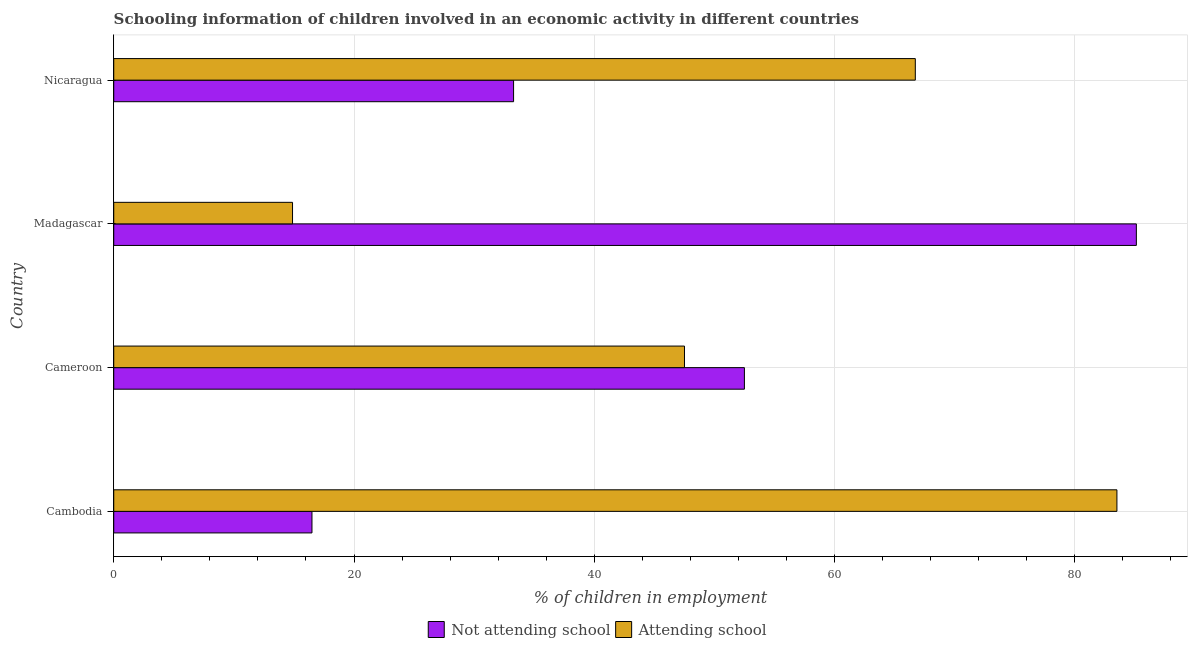Are the number of bars per tick equal to the number of legend labels?
Your response must be concise. Yes. Are the number of bars on each tick of the Y-axis equal?
Your answer should be compact. Yes. How many bars are there on the 2nd tick from the bottom?
Your answer should be very brief. 2. What is the label of the 1st group of bars from the top?
Your answer should be compact. Nicaragua. What is the percentage of employed children who are not attending school in Madagascar?
Your answer should be very brief. 85.12. Across all countries, what is the maximum percentage of employed children who are attending school?
Offer a very short reply. 83.5. Across all countries, what is the minimum percentage of employed children who are not attending school?
Keep it short and to the point. 16.5. In which country was the percentage of employed children who are not attending school maximum?
Your response must be concise. Madagascar. In which country was the percentage of employed children who are attending school minimum?
Provide a short and direct response. Madagascar. What is the total percentage of employed children who are not attending school in the graph?
Provide a short and direct response. 187.39. What is the difference between the percentage of employed children who are not attending school in Cameroon and that in Nicaragua?
Give a very brief answer. 19.21. What is the difference between the percentage of employed children who are not attending school in Madagascar and the percentage of employed children who are attending school in Cambodia?
Your response must be concise. 1.62. What is the average percentage of employed children who are attending school per country?
Ensure brevity in your answer.  53.15. In how many countries, is the percentage of employed children who are attending school greater than 60 %?
Provide a short and direct response. 2. What is the ratio of the percentage of employed children who are not attending school in Cameroon to that in Nicaragua?
Your answer should be very brief. 1.58. Is the percentage of employed children who are attending school in Cambodia less than that in Cameroon?
Keep it short and to the point. No. Is the difference between the percentage of employed children who are not attending school in Cambodia and Madagascar greater than the difference between the percentage of employed children who are attending school in Cambodia and Madagascar?
Your response must be concise. No. What is the difference between the highest and the second highest percentage of employed children who are attending school?
Offer a terse response. 16.78. What is the difference between the highest and the lowest percentage of employed children who are attending school?
Your answer should be very brief. 68.62. Is the sum of the percentage of employed children who are attending school in Cameroon and Nicaragua greater than the maximum percentage of employed children who are not attending school across all countries?
Provide a succinct answer. Yes. What does the 2nd bar from the top in Nicaragua represents?
Make the answer very short. Not attending school. What does the 1st bar from the bottom in Cambodia represents?
Ensure brevity in your answer.  Not attending school. Are the values on the major ticks of X-axis written in scientific E-notation?
Ensure brevity in your answer.  No. Does the graph contain any zero values?
Keep it short and to the point. No. How many legend labels are there?
Your response must be concise. 2. How are the legend labels stacked?
Offer a very short reply. Horizontal. What is the title of the graph?
Your answer should be compact. Schooling information of children involved in an economic activity in different countries. What is the label or title of the X-axis?
Provide a succinct answer. % of children in employment. What is the label or title of the Y-axis?
Your answer should be very brief. Country. What is the % of children in employment in Not attending school in Cambodia?
Provide a short and direct response. 16.5. What is the % of children in employment in Attending school in Cambodia?
Offer a very short reply. 83.5. What is the % of children in employment in Not attending school in Cameroon?
Provide a short and direct response. 52.49. What is the % of children in employment in Attending school in Cameroon?
Make the answer very short. 47.51. What is the % of children in employment in Not attending school in Madagascar?
Provide a succinct answer. 85.12. What is the % of children in employment in Attending school in Madagascar?
Give a very brief answer. 14.88. What is the % of children in employment of Not attending school in Nicaragua?
Ensure brevity in your answer.  33.28. What is the % of children in employment in Attending school in Nicaragua?
Your answer should be very brief. 66.72. Across all countries, what is the maximum % of children in employment of Not attending school?
Your answer should be compact. 85.12. Across all countries, what is the maximum % of children in employment of Attending school?
Ensure brevity in your answer.  83.5. Across all countries, what is the minimum % of children in employment in Attending school?
Keep it short and to the point. 14.88. What is the total % of children in employment in Not attending school in the graph?
Provide a short and direct response. 187.39. What is the total % of children in employment of Attending school in the graph?
Offer a terse response. 212.61. What is the difference between the % of children in employment of Not attending school in Cambodia and that in Cameroon?
Keep it short and to the point. -35.99. What is the difference between the % of children in employment of Attending school in Cambodia and that in Cameroon?
Provide a short and direct response. 35.99. What is the difference between the % of children in employment of Not attending school in Cambodia and that in Madagascar?
Your answer should be very brief. -68.62. What is the difference between the % of children in employment of Attending school in Cambodia and that in Madagascar?
Make the answer very short. 68.62. What is the difference between the % of children in employment of Not attending school in Cambodia and that in Nicaragua?
Offer a very short reply. -16.78. What is the difference between the % of children in employment of Attending school in Cambodia and that in Nicaragua?
Your response must be concise. 16.78. What is the difference between the % of children in employment in Not attending school in Cameroon and that in Madagascar?
Offer a very short reply. -32.62. What is the difference between the % of children in employment of Attending school in Cameroon and that in Madagascar?
Provide a succinct answer. 32.62. What is the difference between the % of children in employment of Not attending school in Cameroon and that in Nicaragua?
Ensure brevity in your answer.  19.21. What is the difference between the % of children in employment of Attending school in Cameroon and that in Nicaragua?
Give a very brief answer. -19.21. What is the difference between the % of children in employment of Not attending school in Madagascar and that in Nicaragua?
Make the answer very short. 51.84. What is the difference between the % of children in employment of Attending school in Madagascar and that in Nicaragua?
Ensure brevity in your answer.  -51.84. What is the difference between the % of children in employment in Not attending school in Cambodia and the % of children in employment in Attending school in Cameroon?
Give a very brief answer. -31.01. What is the difference between the % of children in employment of Not attending school in Cambodia and the % of children in employment of Attending school in Madagascar?
Give a very brief answer. 1.62. What is the difference between the % of children in employment of Not attending school in Cambodia and the % of children in employment of Attending school in Nicaragua?
Provide a succinct answer. -50.22. What is the difference between the % of children in employment of Not attending school in Cameroon and the % of children in employment of Attending school in Madagascar?
Provide a succinct answer. 37.61. What is the difference between the % of children in employment in Not attending school in Cameroon and the % of children in employment in Attending school in Nicaragua?
Provide a short and direct response. -14.22. What is the difference between the % of children in employment in Not attending school in Madagascar and the % of children in employment in Attending school in Nicaragua?
Your answer should be compact. 18.4. What is the average % of children in employment in Not attending school per country?
Your response must be concise. 46.85. What is the average % of children in employment of Attending school per country?
Offer a terse response. 53.15. What is the difference between the % of children in employment in Not attending school and % of children in employment in Attending school in Cambodia?
Make the answer very short. -67. What is the difference between the % of children in employment of Not attending school and % of children in employment of Attending school in Cameroon?
Offer a terse response. 4.99. What is the difference between the % of children in employment of Not attending school and % of children in employment of Attending school in Madagascar?
Your answer should be very brief. 70.24. What is the difference between the % of children in employment of Not attending school and % of children in employment of Attending school in Nicaragua?
Offer a terse response. -33.44. What is the ratio of the % of children in employment in Not attending school in Cambodia to that in Cameroon?
Keep it short and to the point. 0.31. What is the ratio of the % of children in employment in Attending school in Cambodia to that in Cameroon?
Your answer should be compact. 1.76. What is the ratio of the % of children in employment in Not attending school in Cambodia to that in Madagascar?
Offer a very short reply. 0.19. What is the ratio of the % of children in employment of Attending school in Cambodia to that in Madagascar?
Your answer should be compact. 5.61. What is the ratio of the % of children in employment in Not attending school in Cambodia to that in Nicaragua?
Offer a terse response. 0.5. What is the ratio of the % of children in employment of Attending school in Cambodia to that in Nicaragua?
Your answer should be very brief. 1.25. What is the ratio of the % of children in employment of Not attending school in Cameroon to that in Madagascar?
Your response must be concise. 0.62. What is the ratio of the % of children in employment of Attending school in Cameroon to that in Madagascar?
Provide a succinct answer. 3.19. What is the ratio of the % of children in employment in Not attending school in Cameroon to that in Nicaragua?
Your answer should be compact. 1.58. What is the ratio of the % of children in employment of Attending school in Cameroon to that in Nicaragua?
Offer a very short reply. 0.71. What is the ratio of the % of children in employment of Not attending school in Madagascar to that in Nicaragua?
Your response must be concise. 2.56. What is the ratio of the % of children in employment of Attending school in Madagascar to that in Nicaragua?
Provide a succinct answer. 0.22. What is the difference between the highest and the second highest % of children in employment of Not attending school?
Your answer should be compact. 32.62. What is the difference between the highest and the second highest % of children in employment of Attending school?
Your answer should be very brief. 16.78. What is the difference between the highest and the lowest % of children in employment of Not attending school?
Make the answer very short. 68.62. What is the difference between the highest and the lowest % of children in employment of Attending school?
Make the answer very short. 68.62. 